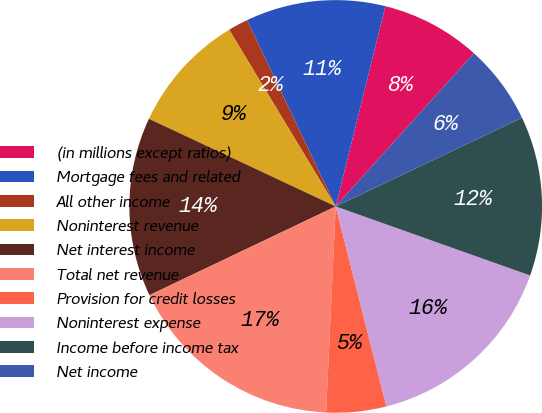Convert chart. <chart><loc_0><loc_0><loc_500><loc_500><pie_chart><fcel>(in millions except ratios)<fcel>Mortgage fees and related<fcel>All other income<fcel>Noninterest revenue<fcel>Net interest income<fcel>Total net revenue<fcel>Provision for credit losses<fcel>Noninterest expense<fcel>Income before income tax<fcel>Net income<nl><fcel>7.81%<fcel>10.94%<fcel>1.57%<fcel>9.38%<fcel>14.06%<fcel>17.18%<fcel>4.69%<fcel>15.62%<fcel>12.5%<fcel>6.25%<nl></chart> 